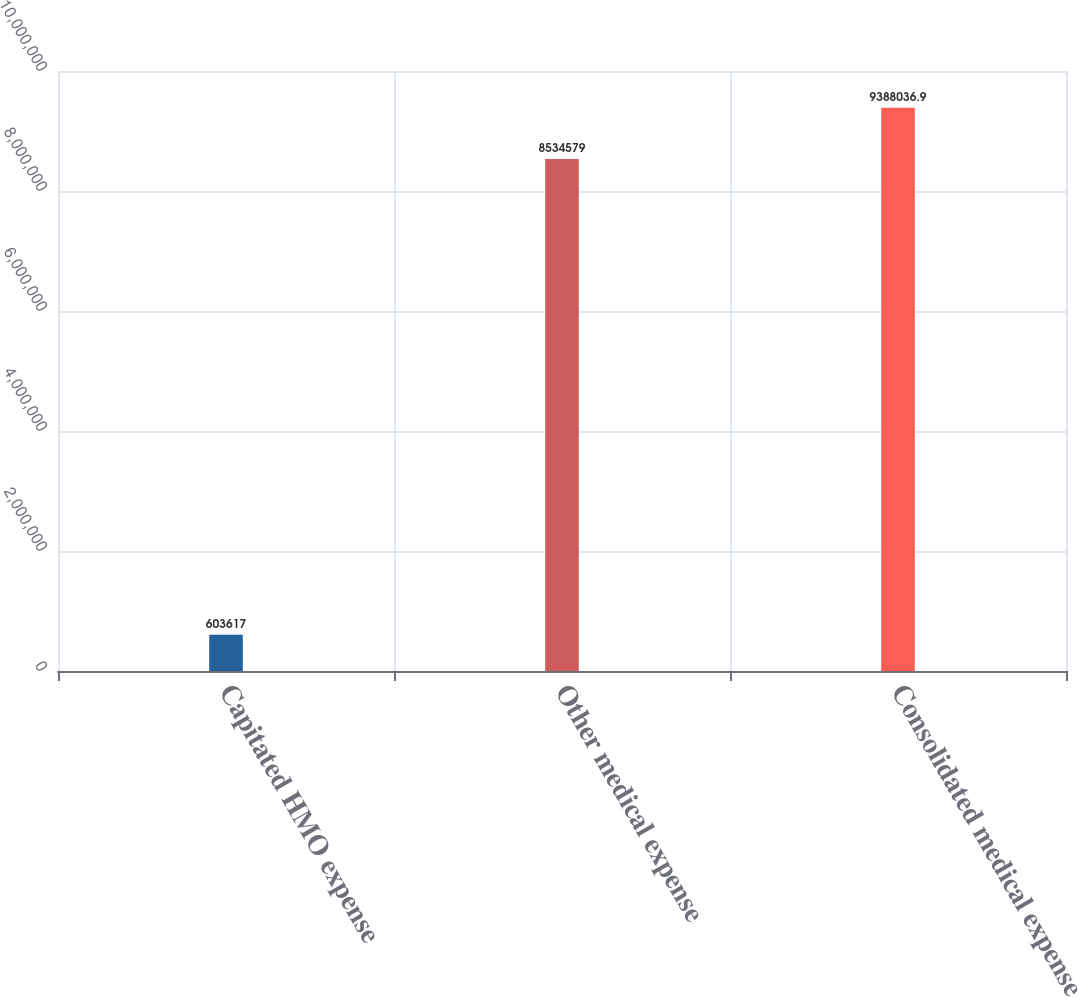<chart> <loc_0><loc_0><loc_500><loc_500><bar_chart><fcel>Capitated HMO expense<fcel>Other medical expense<fcel>Consolidated medical expense<nl><fcel>603617<fcel>8.53458e+06<fcel>9.38804e+06<nl></chart> 